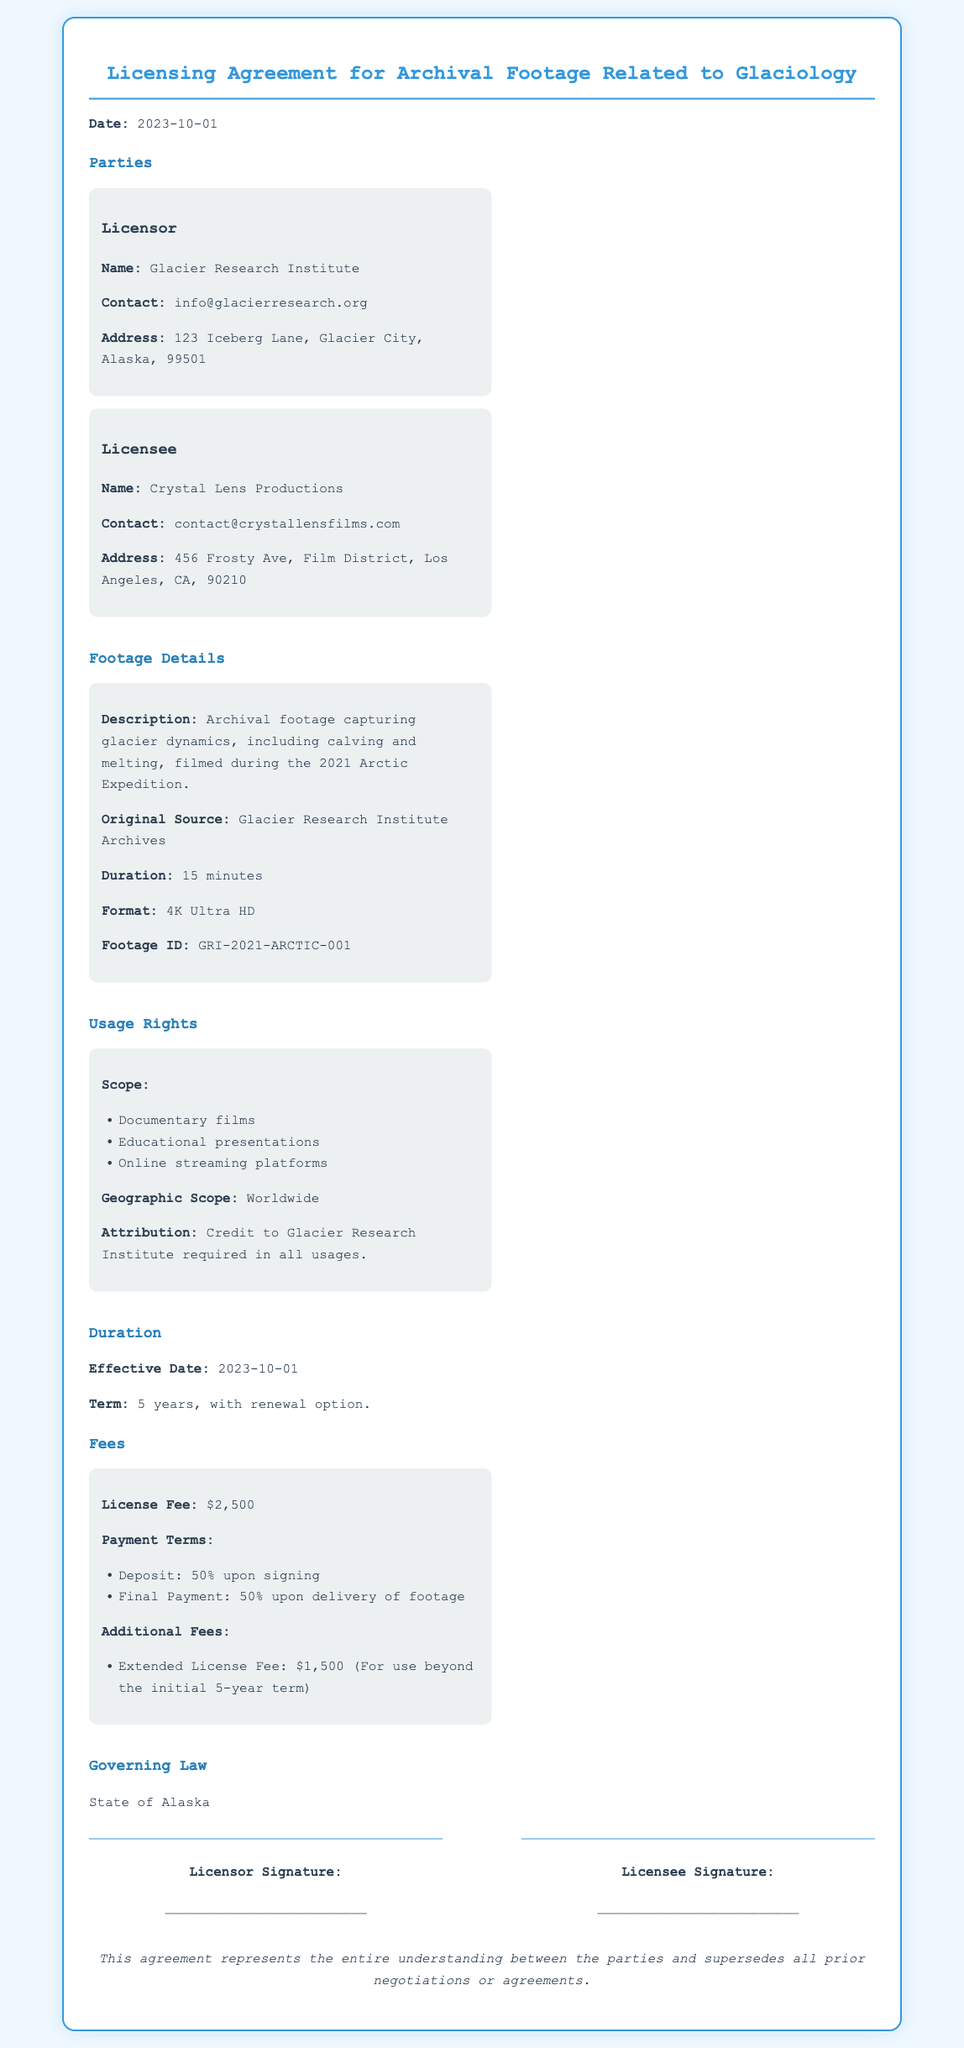What is the effective date of the agreement? The effective date of the agreement is explicitly stated in the document under the Duration section.
Answer: 2023-10-01 Who is the Licensor? The Licensor's name is provided in the Parties section, identifying the organization involved.
Answer: Glacier Research Institute What is the duration of the licensing term? The duration is mentioned as part of the Duration section, providing insight into the licensing timeframe.
Answer: 5 years What is the license fee? The specific fee for the license is detailed under the Fees section, summarizing the payment for usage rights.
Answer: $2,500 What forms of media can the footage be used for? The uses permitted for the footage are outlined under the Usage Rights section, specifying the types of projects allowed.
Answer: Documentary films, Educational presentations, Online streaming platforms What is required for attribution? The document specifies requirements for crediting the Licensor, which is part of the Usage Rights section.
Answer: Credit to Glacier Research Institute What is the additional fee for an extended license? The additional costs associated with extending the license are clearly stated in the Fees section.
Answer: $1,500 What is the governing law for the agreement? The section on Governing Law names the jurisdiction applicable to the agreement.
Answer: State of Alaska What is the format of the footage? The format the footage is provided in is noted in the Footage Details section, giving clarity on the quality standards.
Answer: 4K Ultra HD 